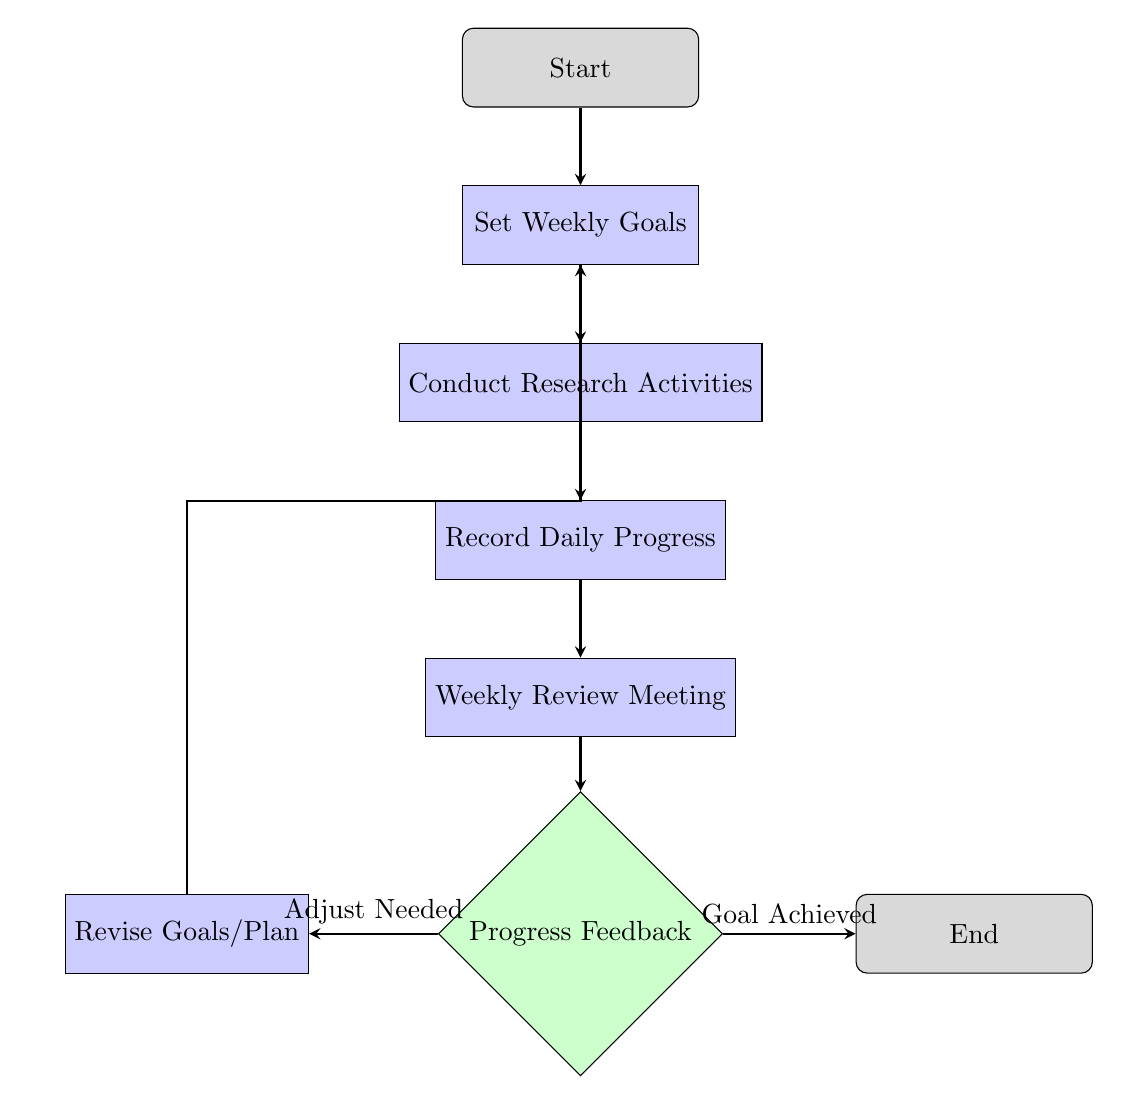What is the starting node in the flowchart? The flowchart begins at the node labeled "Start."
Answer: Start How many nodes are present in the diagram? The diagram contains a total of 8 nodes as listed in the data provided.
Answer: 8 Which node comes after "Set Weekly Goals"? After "Set Weekly Goals," the next node is "Conduct Research Activities."
Answer: Conduct Research Activities What type of node is used for "Progress Feedback"? The node labeled "Progress Feedback" is a decision node, indicating a choice point in the flowchart.
Answer: decision What happens if the progress feedback indicates that the goal is achieved? If "Goal Achieved" is indicated from the feedback, the flow proceeds to the "End" node.
Answer: End What process follows "Record Daily Progress"? Following "Record Daily Progress," the flow continues to the "Weekly Review Meeting."
Answer: Weekly Review Meeting If an adjustment is needed after the progress feedback, where does that lead? If adjustments are needed, it leads to the "Revise Goals/Plan" node, indicating a need to reassess previous decisions.
Answer: Revise Goals/Plan What does the diagram outline as the last step in the weekly research progress tracking system? The last step in the system as per the flowchart is reaching the node labeled "End."
Answer: End 